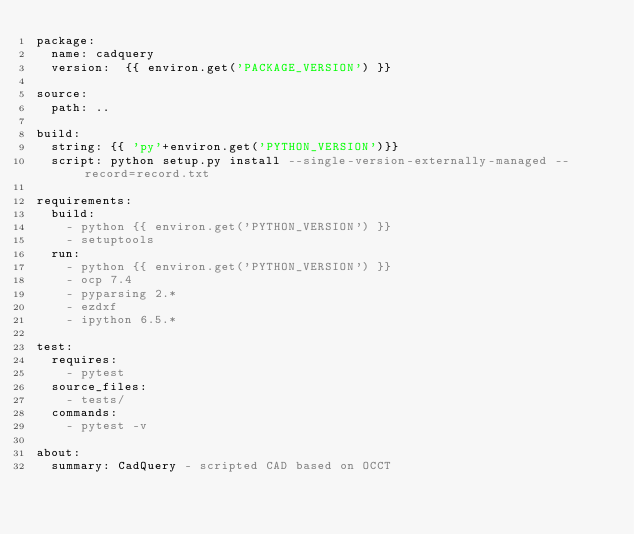<code> <loc_0><loc_0><loc_500><loc_500><_YAML_>package:
  name: cadquery
  version:  {{ environ.get('PACKAGE_VERSION') }}

source:
  path: ..

build:
  string: {{ 'py'+environ.get('PYTHON_VERSION')}}
  script: python setup.py install --single-version-externally-managed --record=record.txt

requirements:
  build:
    - python {{ environ.get('PYTHON_VERSION') }}
    - setuptools
  run:
    - python {{ environ.get('PYTHON_VERSION') }}
    - ocp 7.4
    - pyparsing 2.*
    - ezdxf
    - ipython 6.5.*
    
test:
  requires:
    - pytest	
  source_files:
    - tests/
  commands:
    - pytest -v

about:
  summary: CadQuery - scripted CAD based on OCCT
</code> 